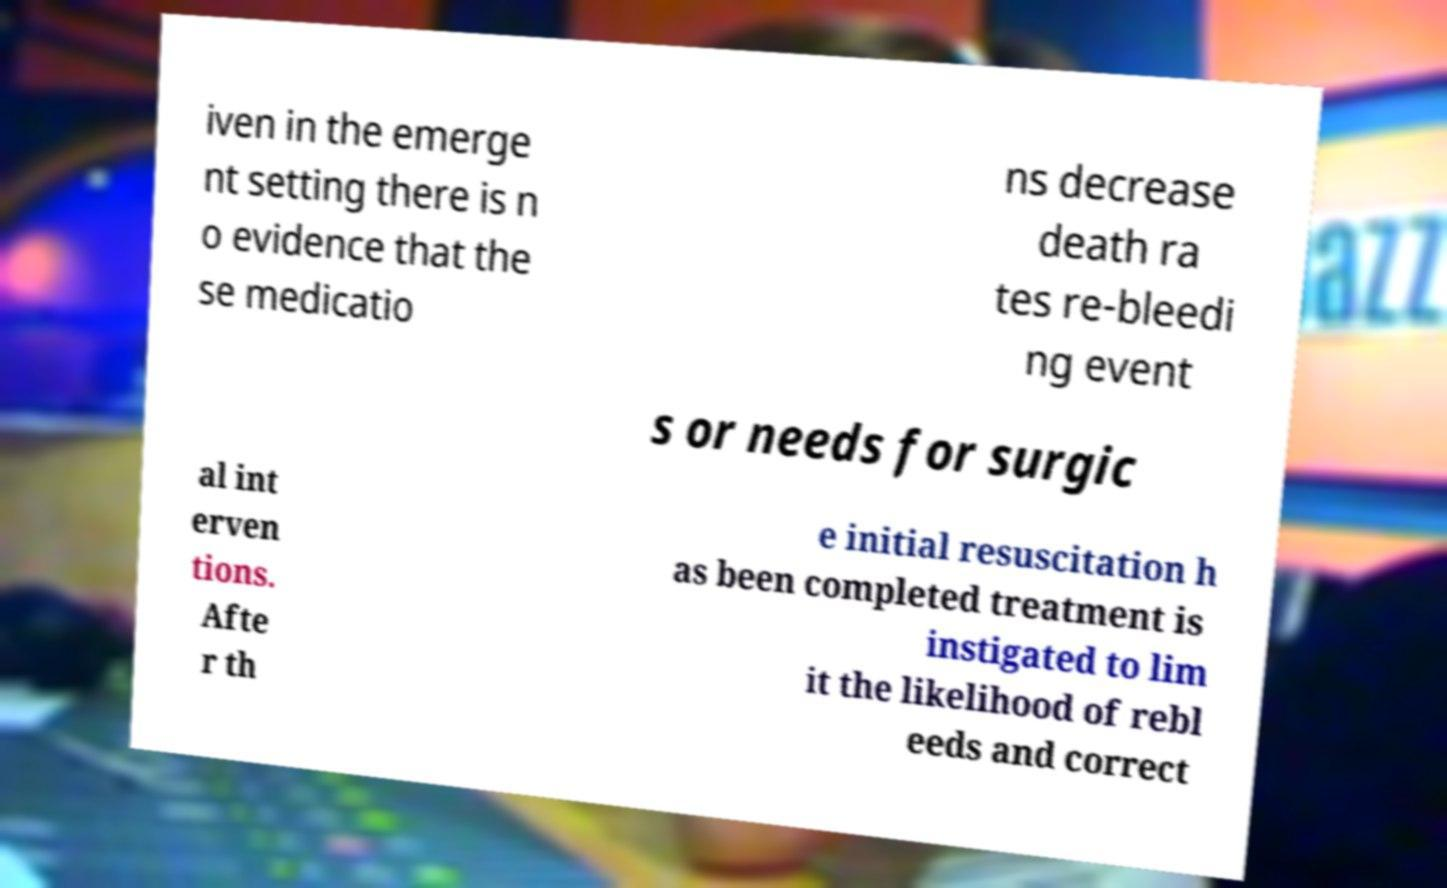Can you accurately transcribe the text from the provided image for me? iven in the emerge nt setting there is n o evidence that the se medicatio ns decrease death ra tes re-bleedi ng event s or needs for surgic al int erven tions. Afte r th e initial resuscitation h as been completed treatment is instigated to lim it the likelihood of rebl eeds and correct 